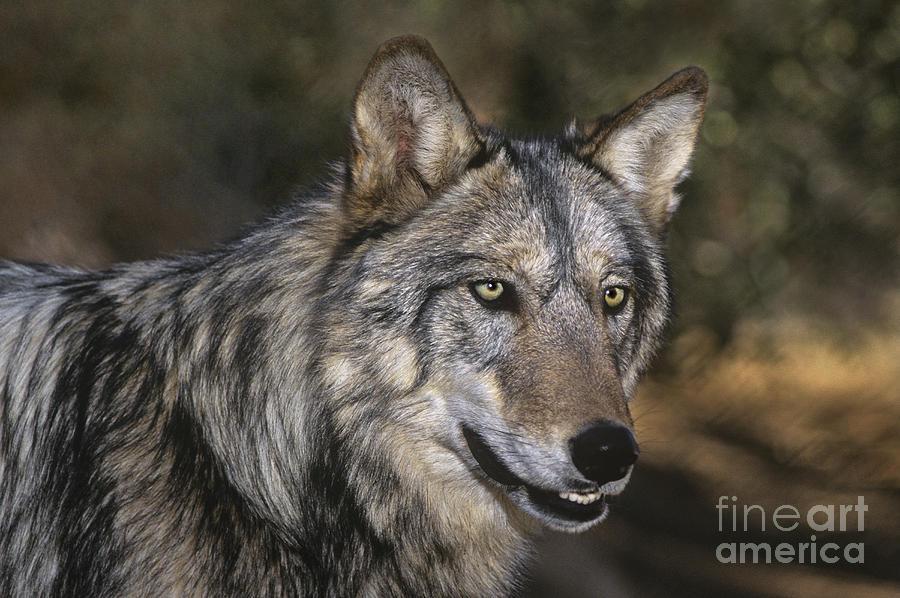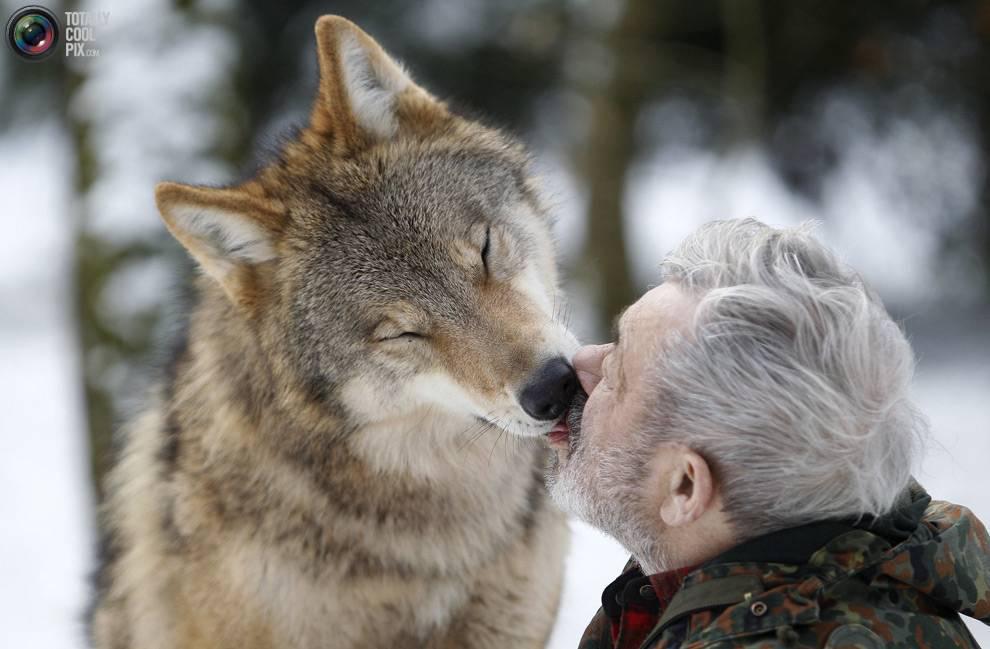The first image is the image on the left, the second image is the image on the right. Assess this claim about the two images: "Both images contain a hunter posing with a dead wolf.". Correct or not? Answer yes or no. No. The first image is the image on the left, the second image is the image on the right. Assess this claim about the two images: "One image shows a nonstanding person posed behind a reclining wolf, and the other other image shows a standing person with arms holding up a wolf.". Correct or not? Answer yes or no. No. 